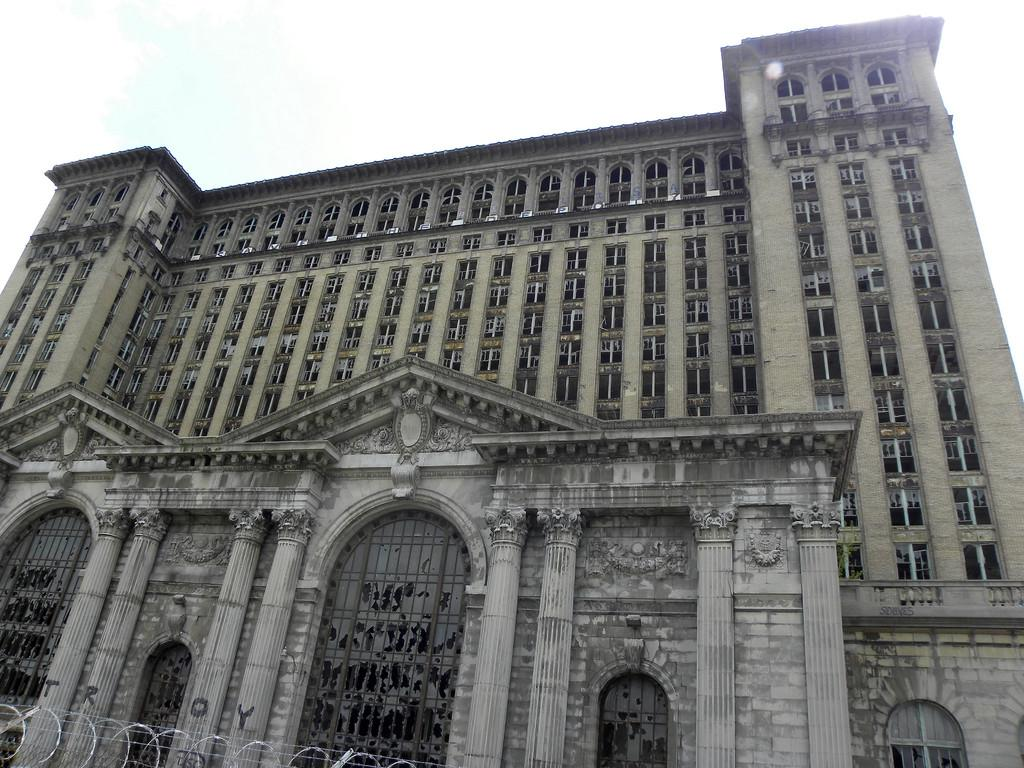What is the main structure in the center of the image? There is a building in the center of the image. What can be seen on the pillars of the building? There are letters on the pillars of the building. What type of barrier is present in the image? There is a fence in the image. What is visible at the top of the image? The sky is visible at the top of the image. What type of polish is being applied to the frogs in the image? There are no frogs present in the image, and therefore no polish is being applied. How many matches are visible in the image? There are no matches present in the image. 